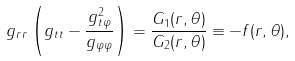<formula> <loc_0><loc_0><loc_500><loc_500>g _ { r r } \left ( g _ { t t } - \frac { g _ { t \varphi } ^ { 2 } } { g _ { \varphi \varphi } } \right ) = \frac { G _ { 1 } ( r , \theta ) } { G _ { 2 } ( r , \theta ) } \equiv - f ( r , \theta ) ,</formula> 